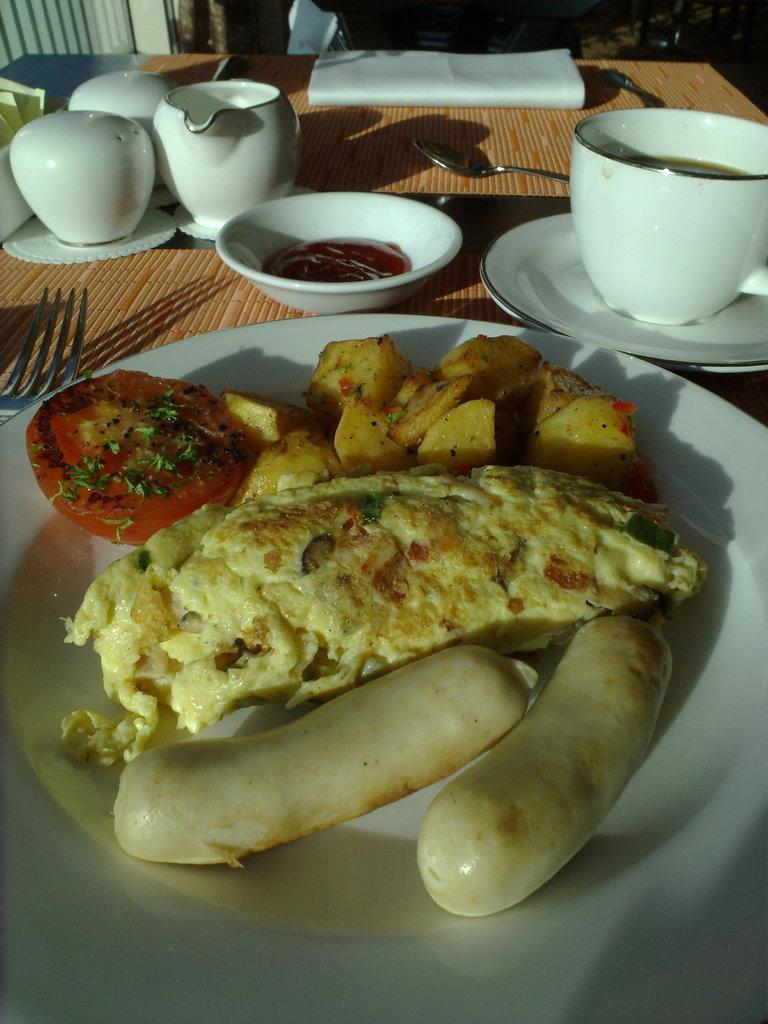Please provide a concise description of this image. There are two sausages, an omelet, potato pieces which are fried and tomato piece which is fried, on the table, on which, there are white color cups, a cup on the saucer, a fork, a spoon and other objects. In the background, there are other objects. 